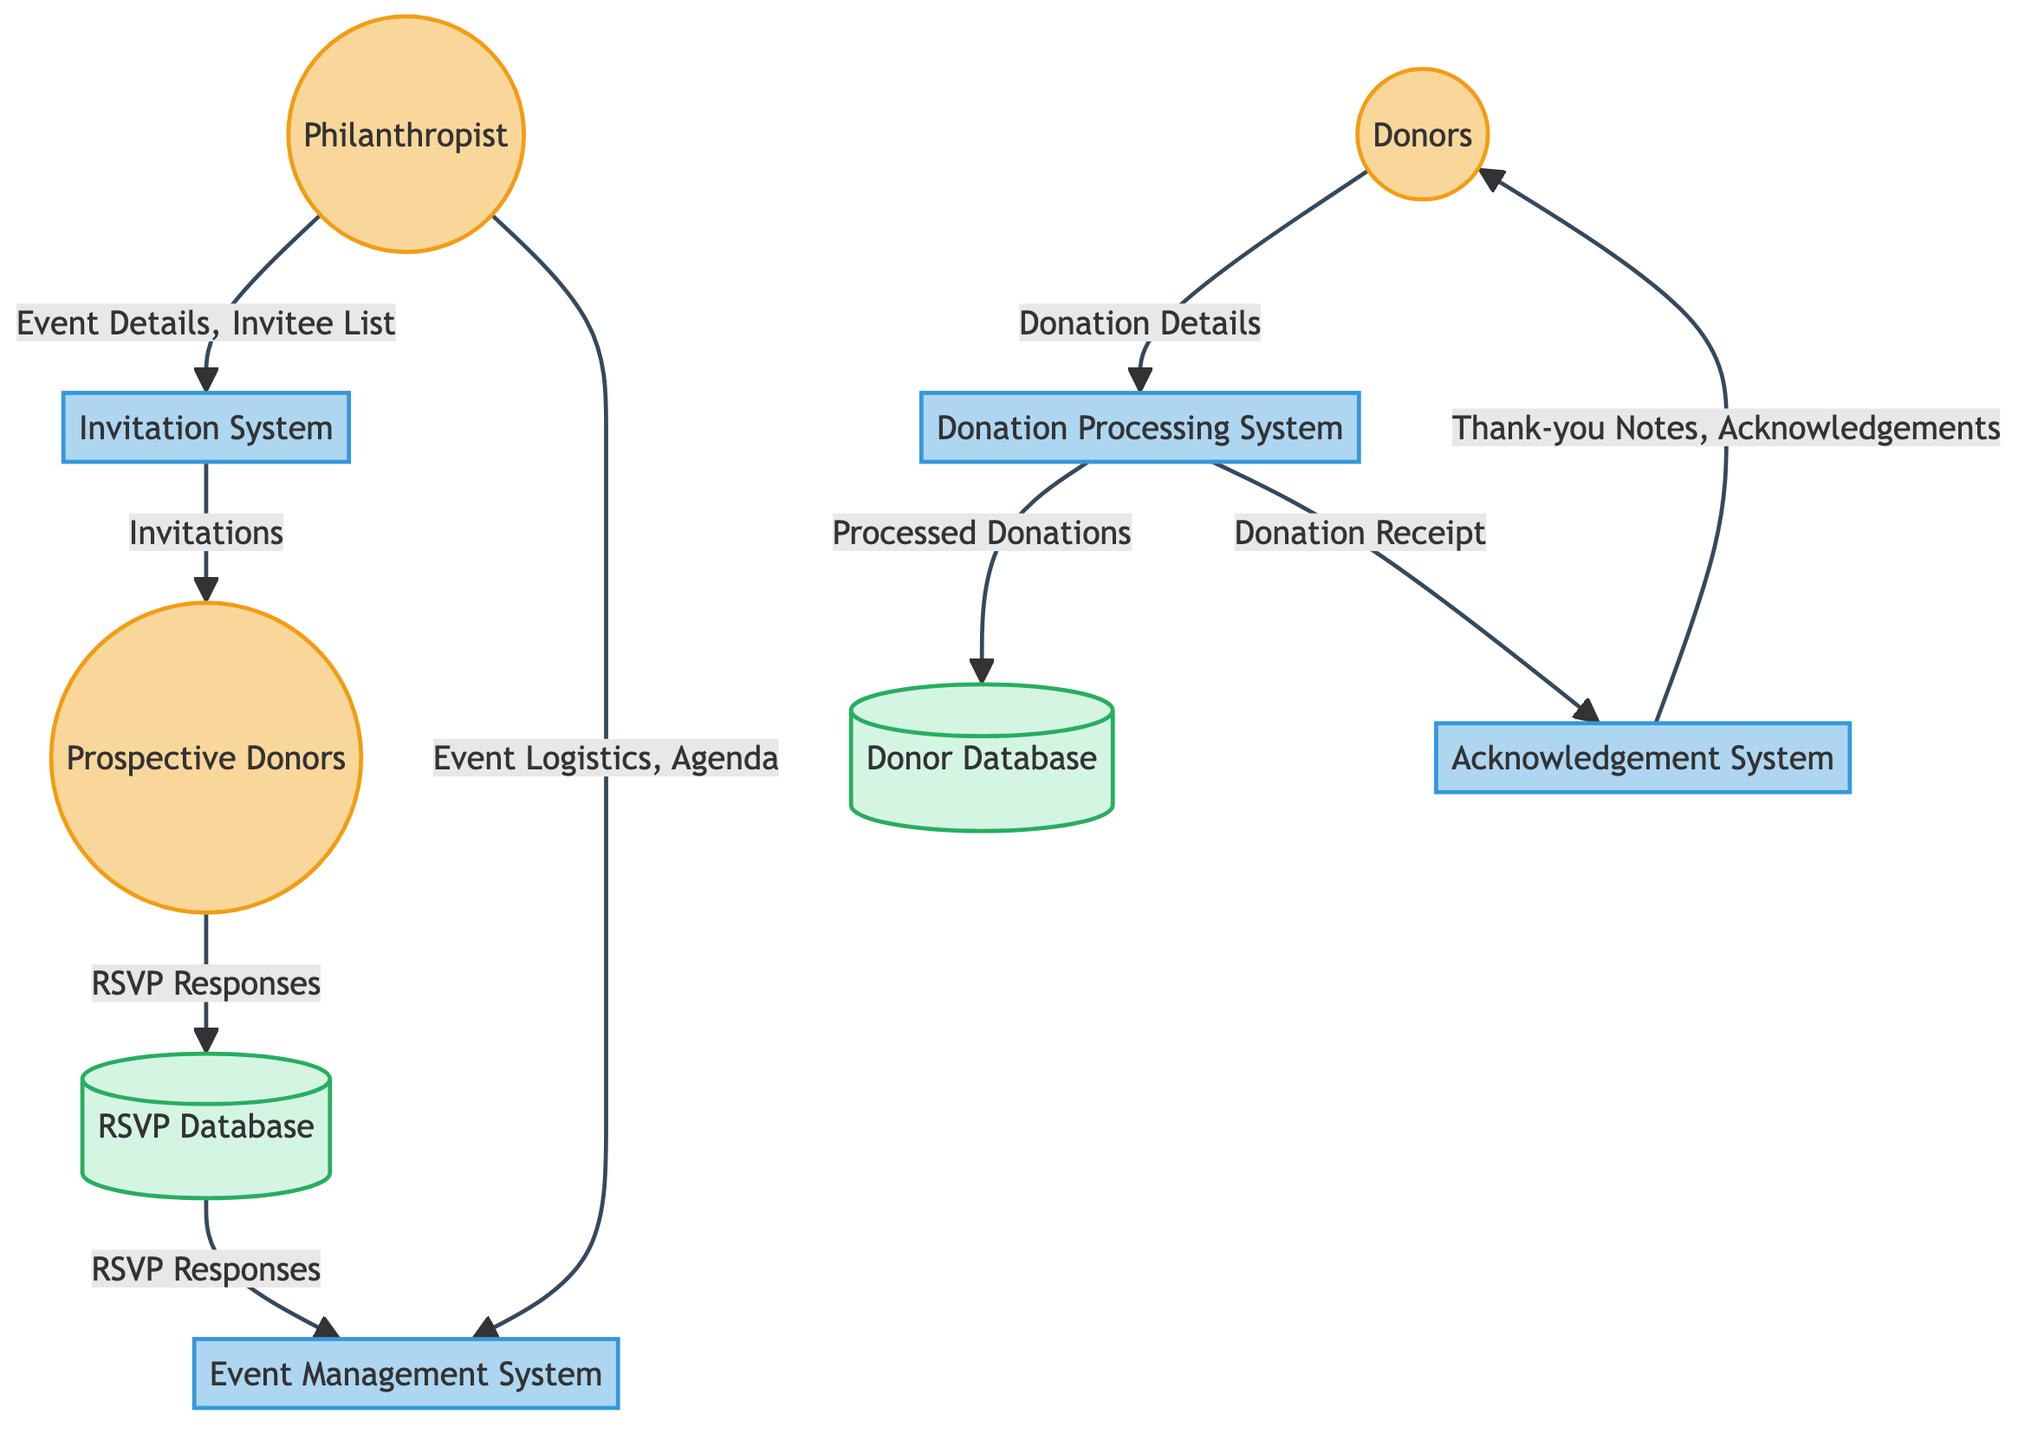What external entity initiates the invitation process? The invitation process is initiated by the Philanthropist, as indicated by the outgoing flow from the Philanthropist to the Invitation System with the data "Event Details, Invitee List."
Answer: Philanthropist How many data stores are represented in the diagram? From the diagram, there are two data stores shown: the RSVP Database and the Donor Database.
Answer: 2 What type of system handles RSVPs from prospective donors? The system responsible for managing RSVP responses from prospective donors is the RSVP Database, which is clearly labeled in the diagram as a data store.
Answer: RSVP Database Which system sends out invitations to prospective donors? The Invitation System is the one that sends out invitations, as seen in the flow from the Invitation System to Prospective Donors with the data "Invitations."
Answer: Invitation System What happens to "Processed Donations" after being handled by the Donation Processing System? After being processed by the Donation Processing System, the "Processed Donations" are stored in the Donor Database, as depicted by the flow leading from the Donation Processing System to the Donor Database.
Answer: Donor Database What data does the Donation Processing System send to the Acknowledgement System? The information sent to the Acknowledgement System from the Donation Processing System is the "Donation Receipt," as indicated by the directed flow between these two systems.
Answer: Donation Receipt How does the Event Management System utilize RSVP responses gathered from donors? The RSVP responses collected from prospective donors are sent to the Event Management System from the RSVP Database, enabling it to finalize the event planning. This function is captured in the arrows showing the movement of "RSVP Responses."
Answer: Finalize event planning Which process directly interacts with the donors to collect their donation details? The process that directly interacts with donors to collect their donation details is the Donation Processing System, which receives "Donation Details" from Donors indicated in the flow.
Answer: Donation Processing System What type of entities are Philanthropist and Prospective Donors categorized as? Both the Philanthropist and Prospective Donors are categorized as External Entities in the diagram, which are indicated by their distinct representation.
Answer: External Entities 